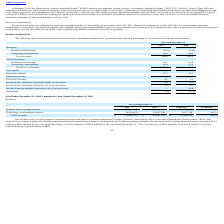According to Luna Innovations Incorporated's financial document, What led to revenues within Technology Development segment to increase from 2018 to 2019? Based on the financial document, the answer is due to additional contract awards, including higher value Phase 2 SBIR contracts.. Also, can you calculate: What is the average Products and licensing revenues for December 31, 2018 and 2019? To answer this question, I need to perform calculations using the financial data. The calculation is: (44,491,041+21,949,689) / 2, which equals 33220365. This is based on the information: "Products and licensing revenues $ 44,491,041 $ 21,949,689 $ 22,541,352 102.7% Products and licensing revenues $ 44,491,041 $ 21,949,689 $ 22,541,352 102.7%..." The key data points involved are: 21,949,689, 44,491,041. Also, can you calculate: What is the average Technology development revenues for December 31, 2018 and 2019? To answer this question, I need to perform calculations using the financial data. The calculation is: (26,024,674+20,967,556) / 2, which equals 23496115. This is based on the information: "Technology development revenues 26,024,674 20,967,556 5,057,118 24.1% Technology development revenues 26,024,674 20,967,556 5,057,118 24.1%..." The key data points involved are: 20,967,556, 26,024,674. Additionally, In which year was Products and licensing revenues less than 40,000,000? According to the financial document, 2018. The relevant text states: "2019 2018 $ Difference % Difference..." Also, What was the increase in the Products and Licensing segment revenue in 2019? According to the financial document, $22.5 million. The relevant text states: "Products and Licensing segment revenues increased $22.5 million to $44.5 million for the year ended December 31, 2019 compared to $21.9 million for the year ended D..." Also, What was the Technology development revenues in 2019 and 2018 respectively? The document shows two values: 26,024,674 and 20,967,556 (in millions). From the document: "Technology development revenues 26,024,674 20,967,556 5,057,118 24.1% Technology development revenues 26,024,674 20,967,556 5,057,118 24.1%..." 